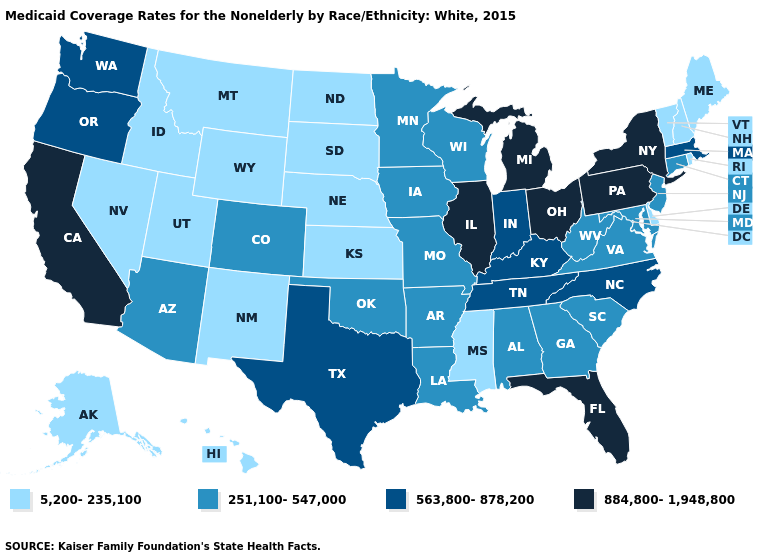Does Ohio have the same value as Nevada?
Keep it brief. No. Does West Virginia have the same value as Wyoming?
Quick response, please. No. Which states hav the highest value in the MidWest?
Give a very brief answer. Illinois, Michigan, Ohio. Among the states that border Utah , which have the highest value?
Answer briefly. Arizona, Colorado. Does the map have missing data?
Answer briefly. No. Among the states that border New Mexico , which have the highest value?
Concise answer only. Texas. Which states have the lowest value in the Northeast?
Quick response, please. Maine, New Hampshire, Rhode Island, Vermont. Among the states that border Georgia , which have the highest value?
Answer briefly. Florida. Name the states that have a value in the range 884,800-1,948,800?
Concise answer only. California, Florida, Illinois, Michigan, New York, Ohio, Pennsylvania. Name the states that have a value in the range 563,800-878,200?
Give a very brief answer. Indiana, Kentucky, Massachusetts, North Carolina, Oregon, Tennessee, Texas, Washington. What is the value of Arizona?
Be succinct. 251,100-547,000. What is the lowest value in the Northeast?
Answer briefly. 5,200-235,100. Name the states that have a value in the range 251,100-547,000?
Give a very brief answer. Alabama, Arizona, Arkansas, Colorado, Connecticut, Georgia, Iowa, Louisiana, Maryland, Minnesota, Missouri, New Jersey, Oklahoma, South Carolina, Virginia, West Virginia, Wisconsin. What is the value of North Dakota?
Short answer required. 5,200-235,100. Does Delaware have the highest value in the South?
Be succinct. No. 